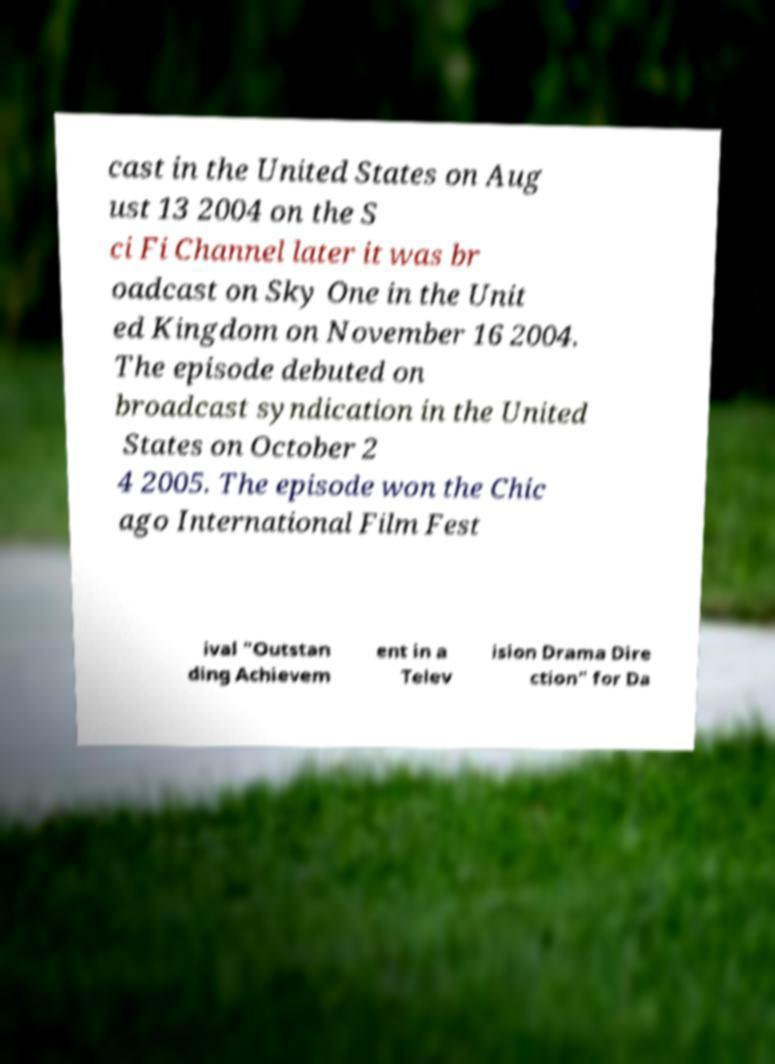Could you extract and type out the text from this image? cast in the United States on Aug ust 13 2004 on the S ci Fi Channel later it was br oadcast on Sky One in the Unit ed Kingdom on November 16 2004. The episode debuted on broadcast syndication in the United States on October 2 4 2005. The episode won the Chic ago International Film Fest ival "Outstan ding Achievem ent in a Telev ision Drama Dire ction" for Da 